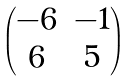Convert formula to latex. <formula><loc_0><loc_0><loc_500><loc_500>\begin{pmatrix} - 6 & - 1 \\ 6 & 5 \end{pmatrix}</formula> 